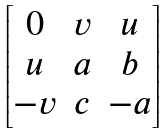Convert formula to latex. <formula><loc_0><loc_0><loc_500><loc_500>\begin{bmatrix} 0 & v & u \\ u & a & b \\ - v & c & - a \end{bmatrix}</formula> 